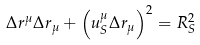Convert formula to latex. <formula><loc_0><loc_0><loc_500><loc_500>\Delta r ^ { \mu } \Delta r _ { \mu } + \left ( u _ { S } ^ { \mu } \Delta r _ { \mu } \right ) ^ { 2 } = R _ { S } ^ { 2 }</formula> 